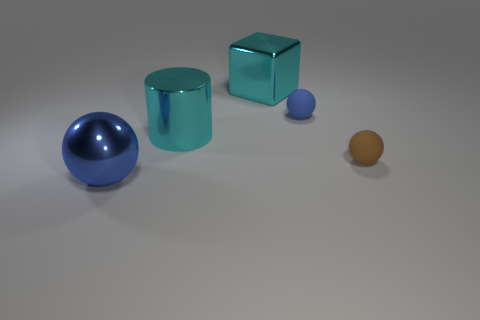Add 2 big cyan cylinders. How many objects exist? 7 Subtract all spheres. How many objects are left? 2 Add 2 blue rubber balls. How many blue rubber balls are left? 3 Add 3 large blue balls. How many large blue balls exist? 4 Subtract 1 brown spheres. How many objects are left? 4 Subtract all cyan things. Subtract all large blue metallic things. How many objects are left? 2 